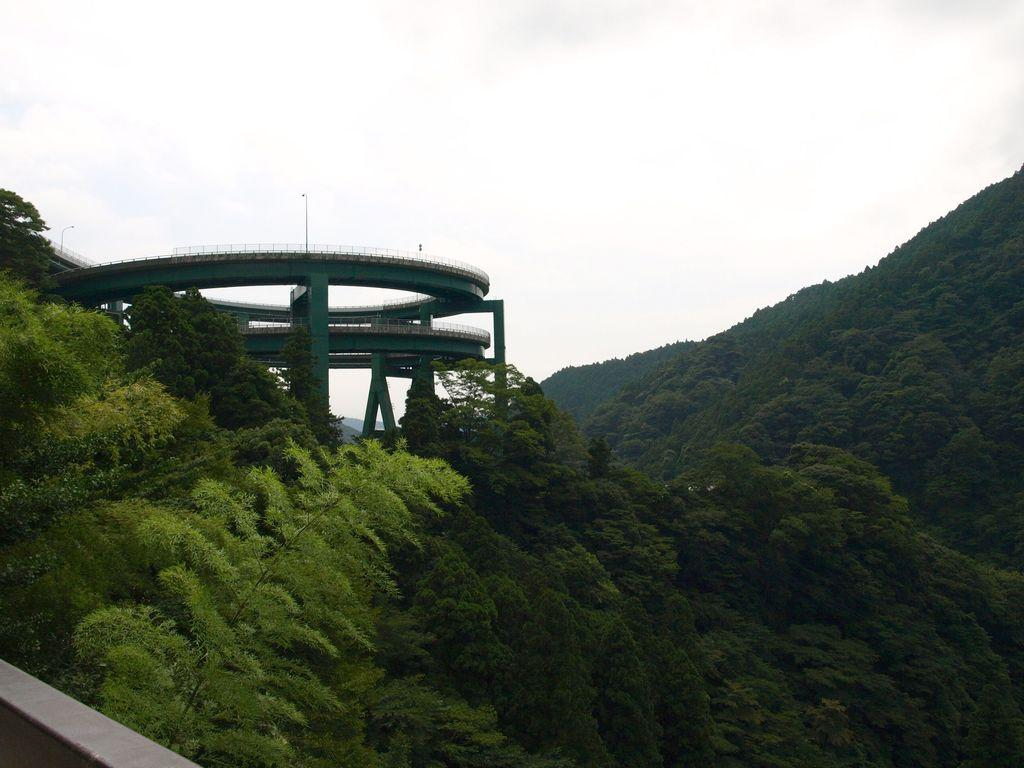What is illuminated on the bridge in the image? There are lights on the bridge in the image. What type of vegetation can be seen in the image? There are trees in the image, and there are also mountains covered with trees. What kind of barrier is present in the image? There is a small wall in the image. What part of the natural environment is visible in the image? The sky is visible in the image. What type of pencil can be seen in the image? There is no pencil present in the image. Is there a judge visible in the image? There is no judge present in the image. 